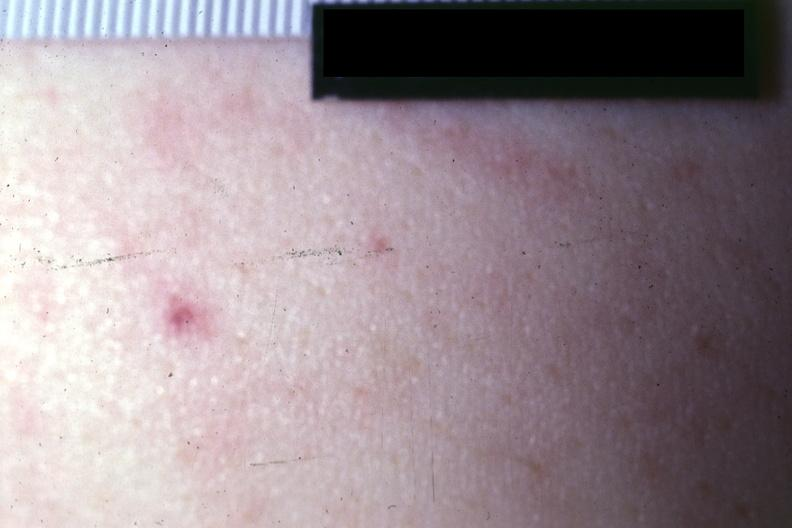what is present?
Answer the question using a single word or phrase. Petechiae 